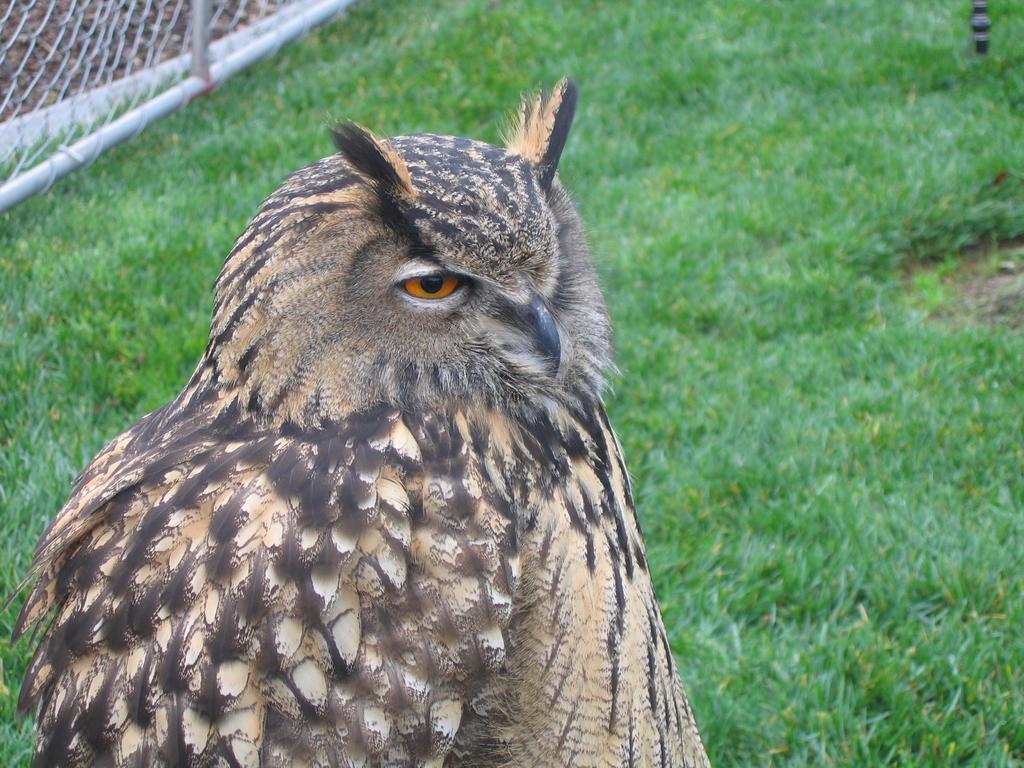How would you summarize this image in a sentence or two? In this picture we can see an owl. Behind the owl, there is grass and wire fencing. 